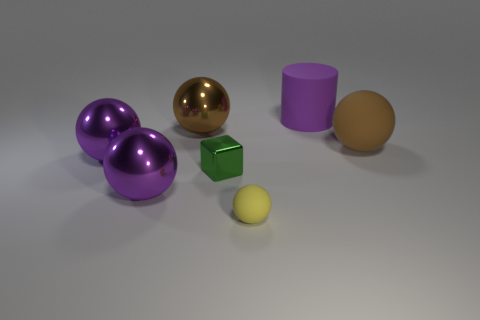What is the color of the large ball right of the brown sphere that is to the left of the sphere to the right of the big purple cylinder?
Your answer should be very brief. Brown. What number of other things are there of the same shape as the small green metallic object?
Your response must be concise. 0. Do the tiny rubber thing and the tiny metal cube have the same color?
Give a very brief answer. No. What number of objects are either brown objects or brown balls that are on the left side of the yellow ball?
Provide a short and direct response. 2. Is there a brown shiny thing of the same size as the yellow rubber sphere?
Make the answer very short. No. Does the small green cube have the same material as the large cylinder?
Keep it short and to the point. No. How many objects are purple metal things or small matte spheres?
Provide a succinct answer. 3. The cylinder has what size?
Provide a succinct answer. Large. Is the number of small rubber things less than the number of small green metal cylinders?
Offer a very short reply. No. How many metallic objects have the same color as the large cylinder?
Make the answer very short. 2. 